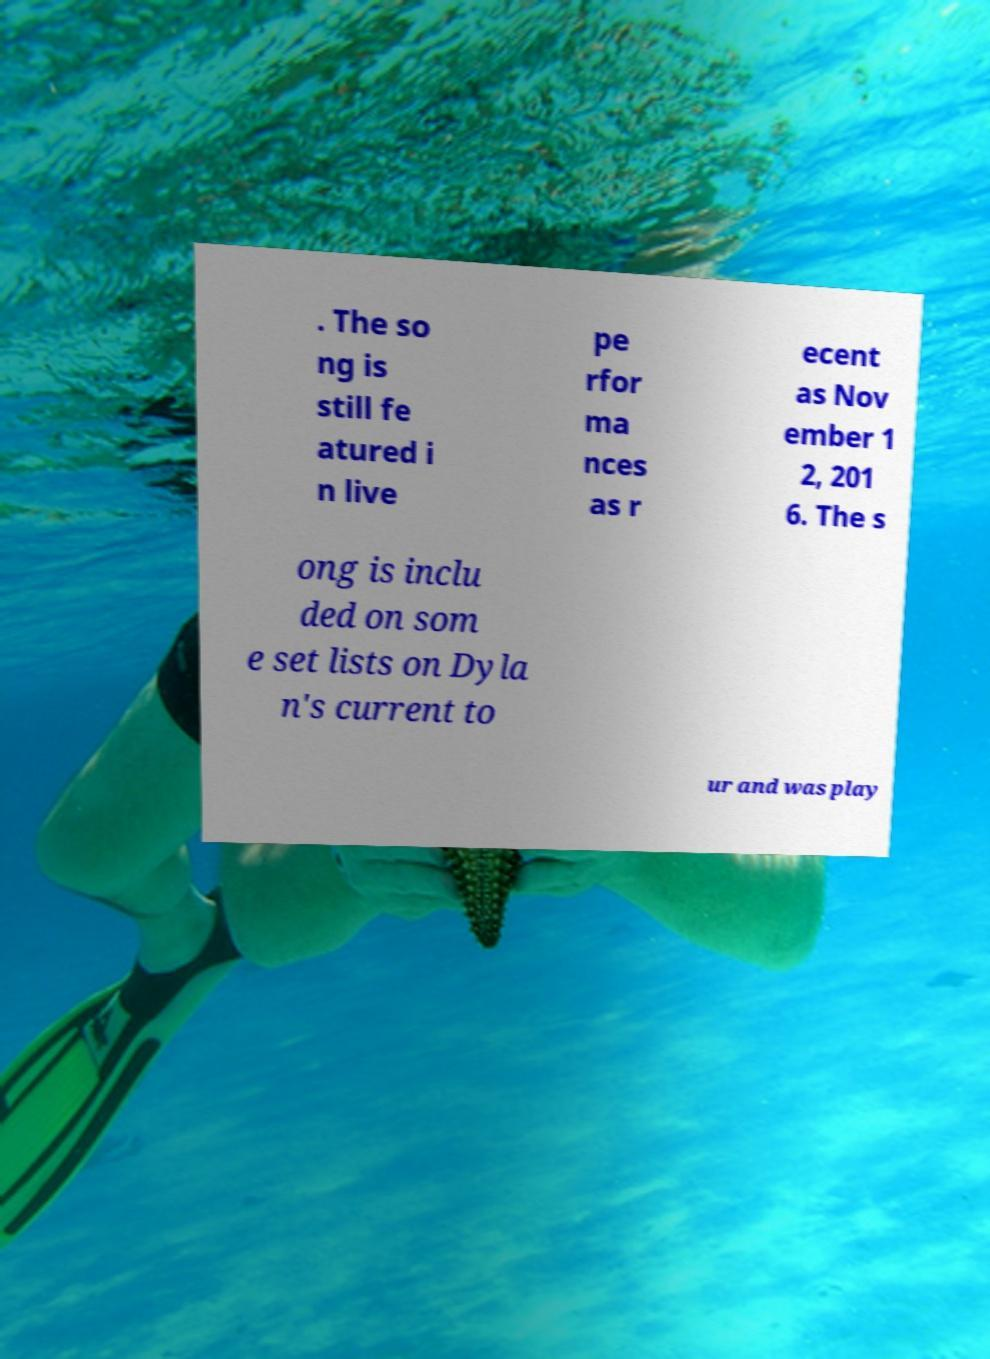I need the written content from this picture converted into text. Can you do that? . The so ng is still fe atured i n live pe rfor ma nces as r ecent as Nov ember 1 2, 201 6. The s ong is inclu ded on som e set lists on Dyla n's current to ur and was play 